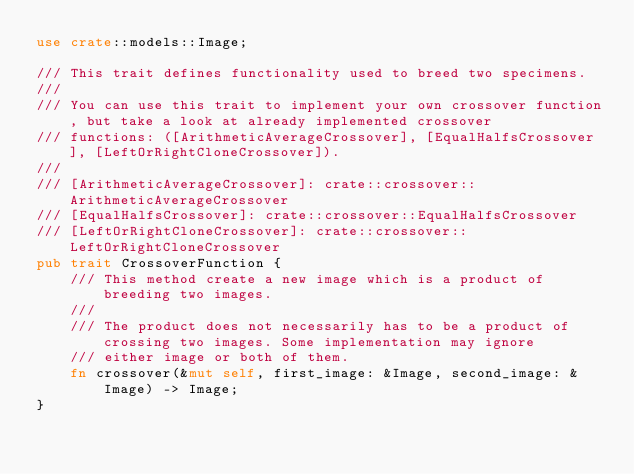Convert code to text. <code><loc_0><loc_0><loc_500><loc_500><_Rust_>use crate::models::Image;

/// This trait defines functionality used to breed two specimens.
///
/// You can use this trait to implement your own crossover function, but take a look at already implemented crossover
/// functions: ([ArithmeticAverageCrossover], [EqualHalfsCrossover], [LeftOrRightCloneCrossover]).
///
/// [ArithmeticAverageCrossover]: crate::crossover::ArithmeticAverageCrossover
/// [EqualHalfsCrossover]: crate::crossover::EqualHalfsCrossover
/// [LeftOrRightCloneCrossover]: crate::crossover::LeftOrRightCloneCrossover
pub trait CrossoverFunction {
    /// This method create a new image which is a product of breeding two images.
    ///
    /// The product does not necessarily has to be a product of crossing two images. Some implementation may ignore
    /// either image or both of them.
    fn crossover(&mut self, first_image: &Image, second_image: &Image) -> Image;
}
</code> 